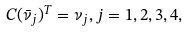<formula> <loc_0><loc_0><loc_500><loc_500>C ( \bar { \nu } _ { j } ) ^ { T } = \nu _ { j } , j = 1 , 2 , 3 , 4 ,</formula> 